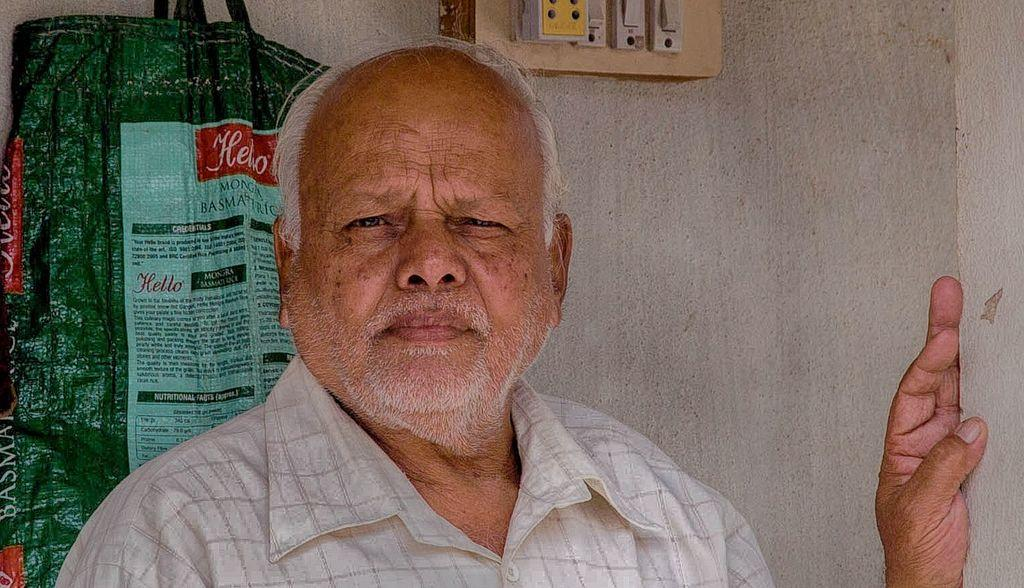Who is present in the image? There is a man in the image. What is the man wearing? The man is wearing a white shirt. What can be seen behind the man? There is a wall behind the man. What is on the wall? There is a switchboard and a sack cover attached to the wall. What type of feather can be seen falling from the man's shirt in the image? There is no feather falling from the man's shirt in the image. What season is depicted in the image? The image does not provide any information about the season, as there are no seasonal cues present. 